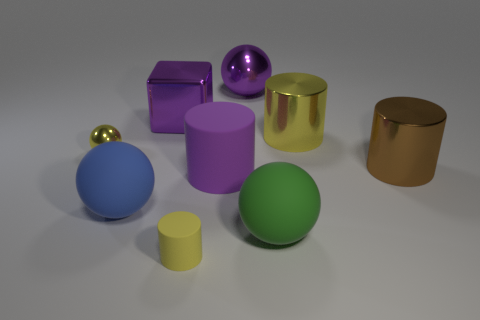What number of other things are the same size as the purple block?
Provide a short and direct response. 6. The sphere that is behind the green rubber ball and on the right side of the large blue rubber ball is made of what material?
Provide a short and direct response. Metal. There is another blue object that is the same shape as the small shiny thing; what is its material?
Give a very brief answer. Rubber. What number of big purple spheres are left of the shiny sphere right of the matte thing that is to the left of the purple block?
Ensure brevity in your answer.  0. Is there anything else of the same color as the tiny cylinder?
Ensure brevity in your answer.  Yes. How many rubber things are both to the left of the large green ball and in front of the blue rubber thing?
Your answer should be very brief. 1. Does the purple metallic object to the right of the large metallic block have the same size as the rubber ball in front of the big blue sphere?
Give a very brief answer. Yes. What number of objects are tiny yellow things that are behind the large purple rubber cylinder or large purple shiny cylinders?
Ensure brevity in your answer.  1. What is the big sphere that is behind the blue ball made of?
Offer a very short reply. Metal. What is the tiny yellow sphere made of?
Keep it short and to the point. Metal. 